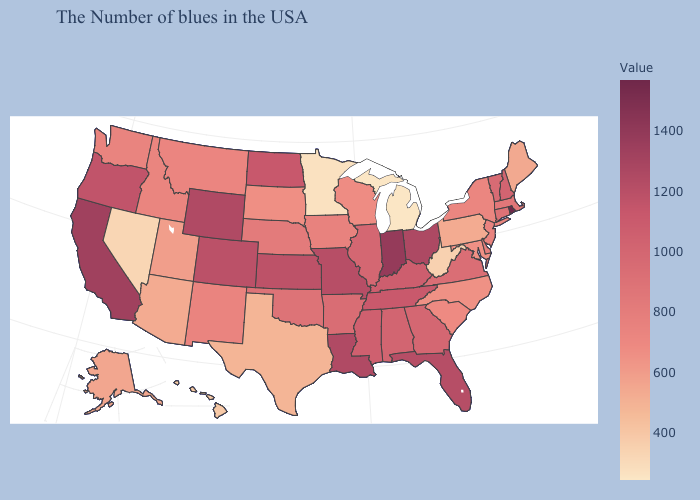Which states have the highest value in the USA?
Answer briefly. Rhode Island. Among the states that border Nevada , does California have the highest value?
Give a very brief answer. Yes. Does Michigan have the lowest value in the MidWest?
Answer briefly. Yes. Does Michigan have the lowest value in the USA?
Concise answer only. Yes. 